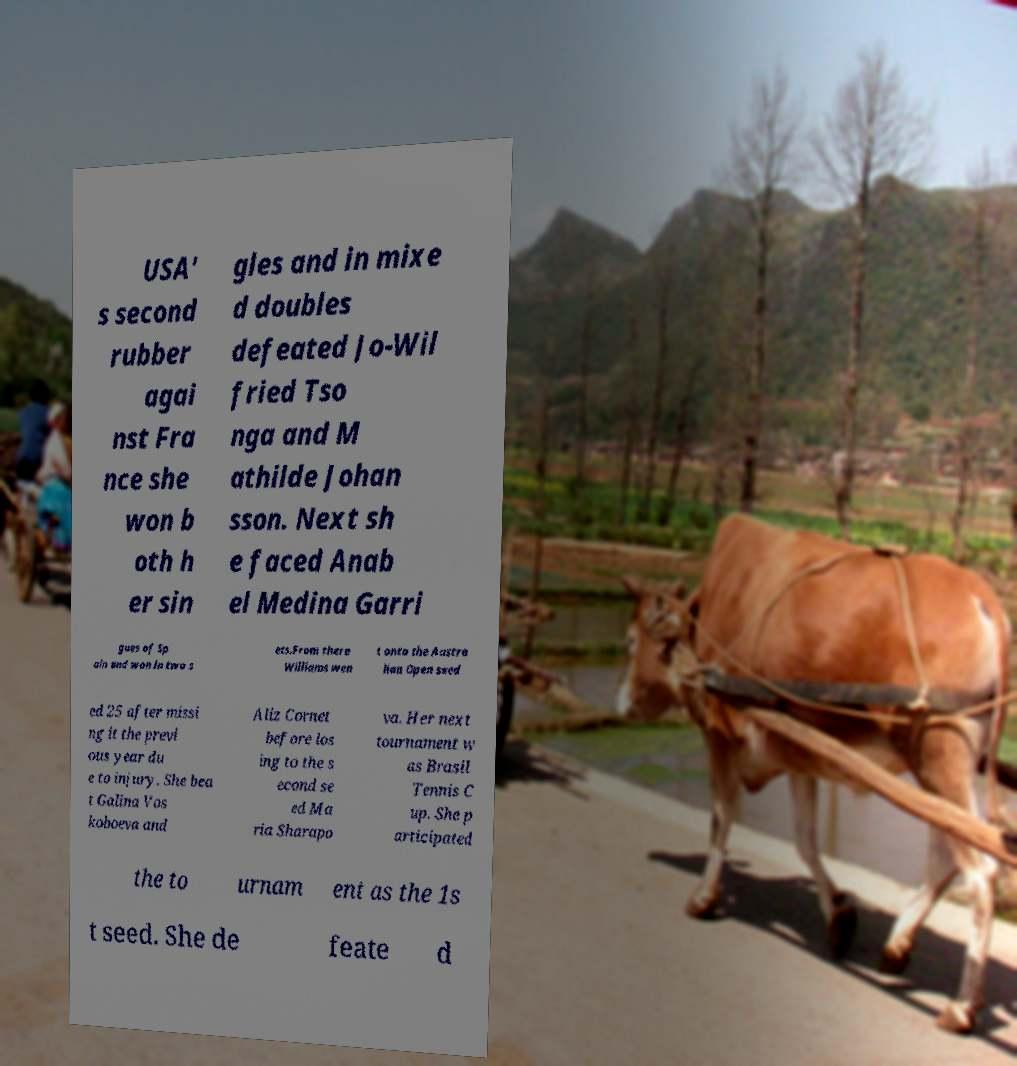Can you read and provide the text displayed in the image?This photo seems to have some interesting text. Can you extract and type it out for me? USA' s second rubber agai nst Fra nce she won b oth h er sin gles and in mixe d doubles defeated Jo-Wil fried Tso nga and M athilde Johan sson. Next sh e faced Anab el Medina Garri gues of Sp ain and won in two s ets.From there Williams wen t onto the Austra lian Open seed ed 25 after missi ng it the previ ous year du e to injury. She bea t Galina Vos koboeva and Aliz Cornet before los ing to the s econd se ed Ma ria Sharapo va. Her next tournament w as Brasil Tennis C up. She p articipated the to urnam ent as the 1s t seed. She de feate d 